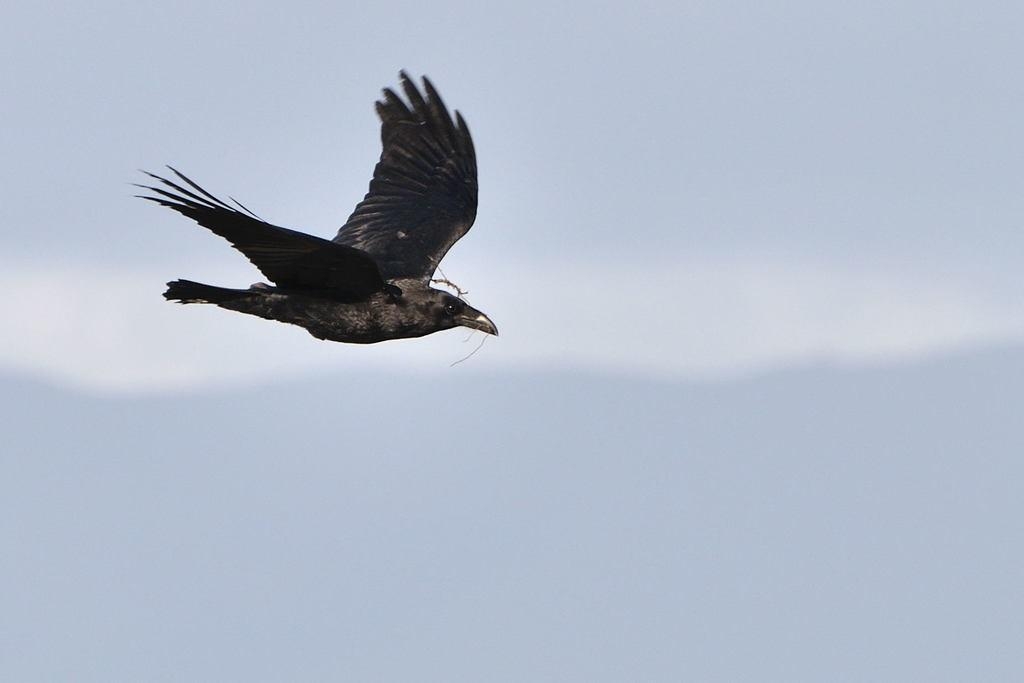What is present in the image? There is a bird in the image. What is the bird doing in the image? The bird is flying in the sky. What type of trees can be seen in the image? There are no trees present in the image; it only features a bird flying in the sky. What book is the bird holding in the image? There is no book present in the image; the bird is simply flying. 